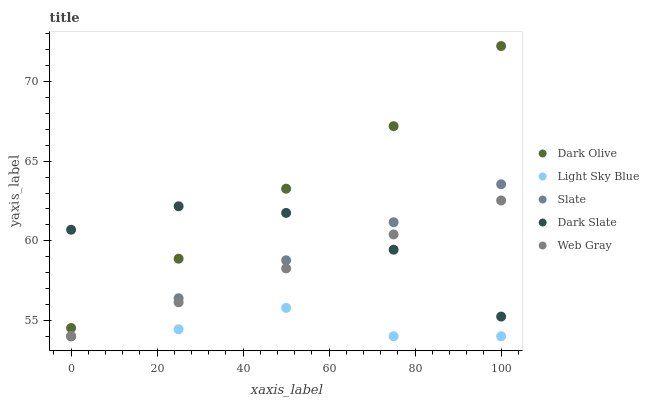Does Light Sky Blue have the minimum area under the curve?
Answer yes or no. Yes. Does Dark Olive have the maximum area under the curve?
Answer yes or no. Yes. Does Slate have the minimum area under the curve?
Answer yes or no. No. Does Slate have the maximum area under the curve?
Answer yes or no. No. Is Web Gray the smoothest?
Answer yes or no. Yes. Is Light Sky Blue the roughest?
Answer yes or no. Yes. Is Slate the smoothest?
Answer yes or no. No. Is Slate the roughest?
Answer yes or no. No. Does Slate have the lowest value?
Answer yes or no. Yes. Does Dark Olive have the lowest value?
Answer yes or no. No. Does Dark Olive have the highest value?
Answer yes or no. Yes. Does Slate have the highest value?
Answer yes or no. No. Is Light Sky Blue less than Dark Slate?
Answer yes or no. Yes. Is Dark Olive greater than Slate?
Answer yes or no. Yes. Does Slate intersect Web Gray?
Answer yes or no. Yes. Is Slate less than Web Gray?
Answer yes or no. No. Is Slate greater than Web Gray?
Answer yes or no. No. Does Light Sky Blue intersect Dark Slate?
Answer yes or no. No. 